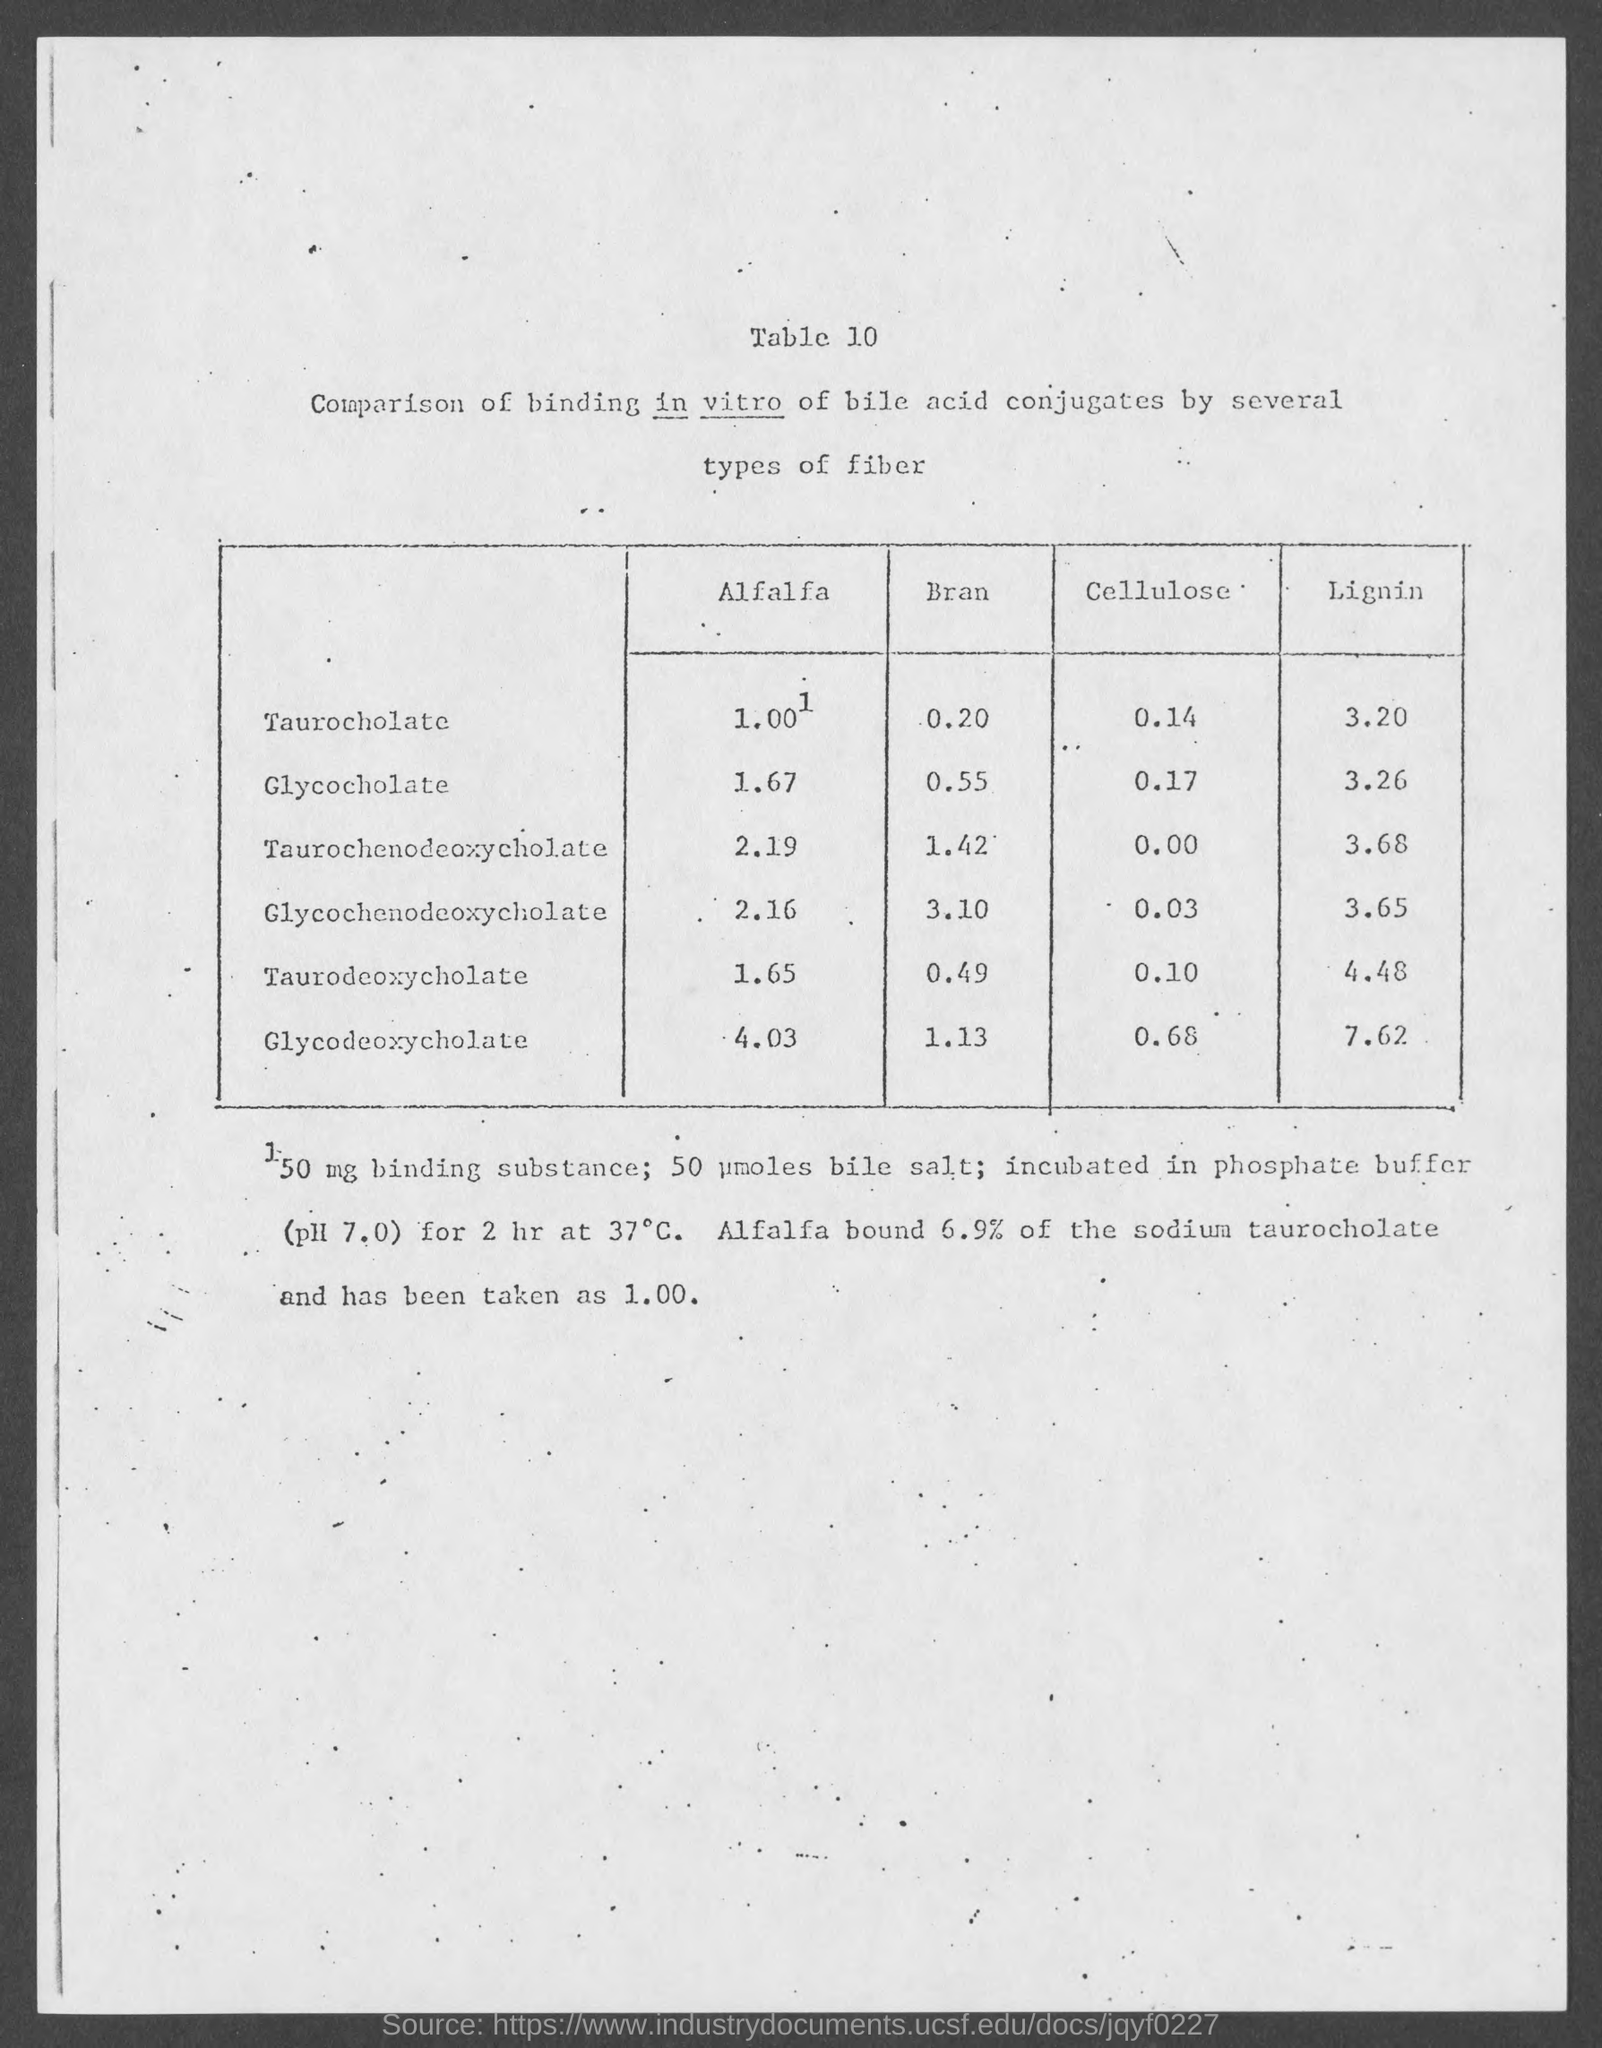Outline some significant characteristics in this image. The value of Taurodeoxycholate in lignin is 4.48. The value of glycocholate in bran is 0.55. The title of the table is "Comparison of binding in vitro of bile acid conjugates by several types of fiber. 